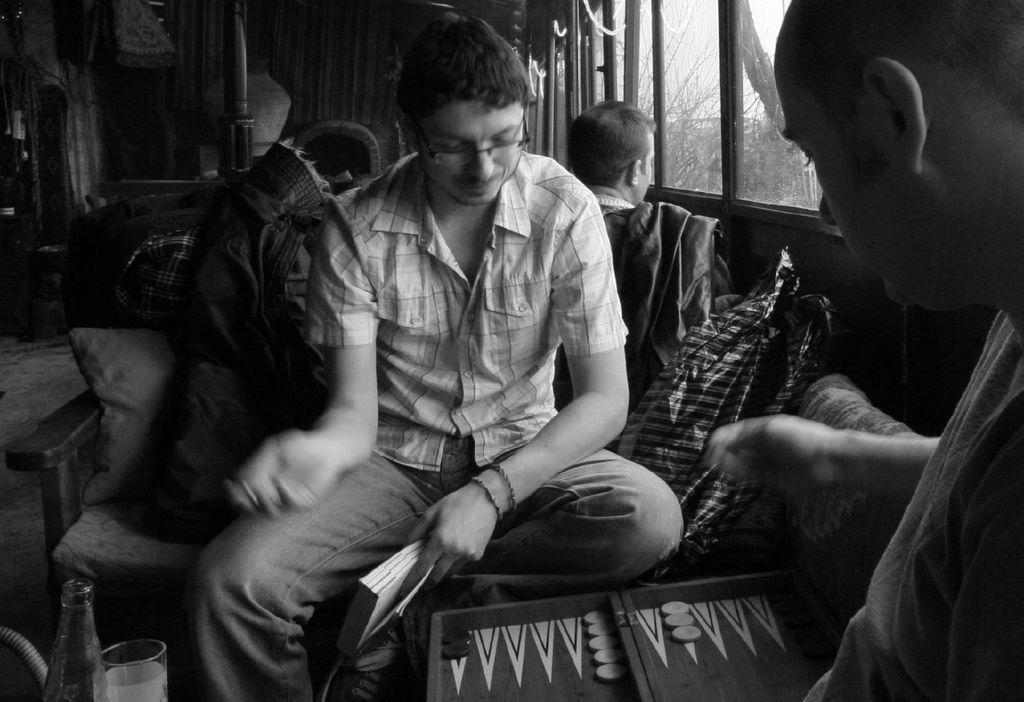Please provide a concise description of this image. In this picture we can see a group of people where a man is holding a book with his hand and smiling, bottle, glass and in the background we can see trees from windows. 